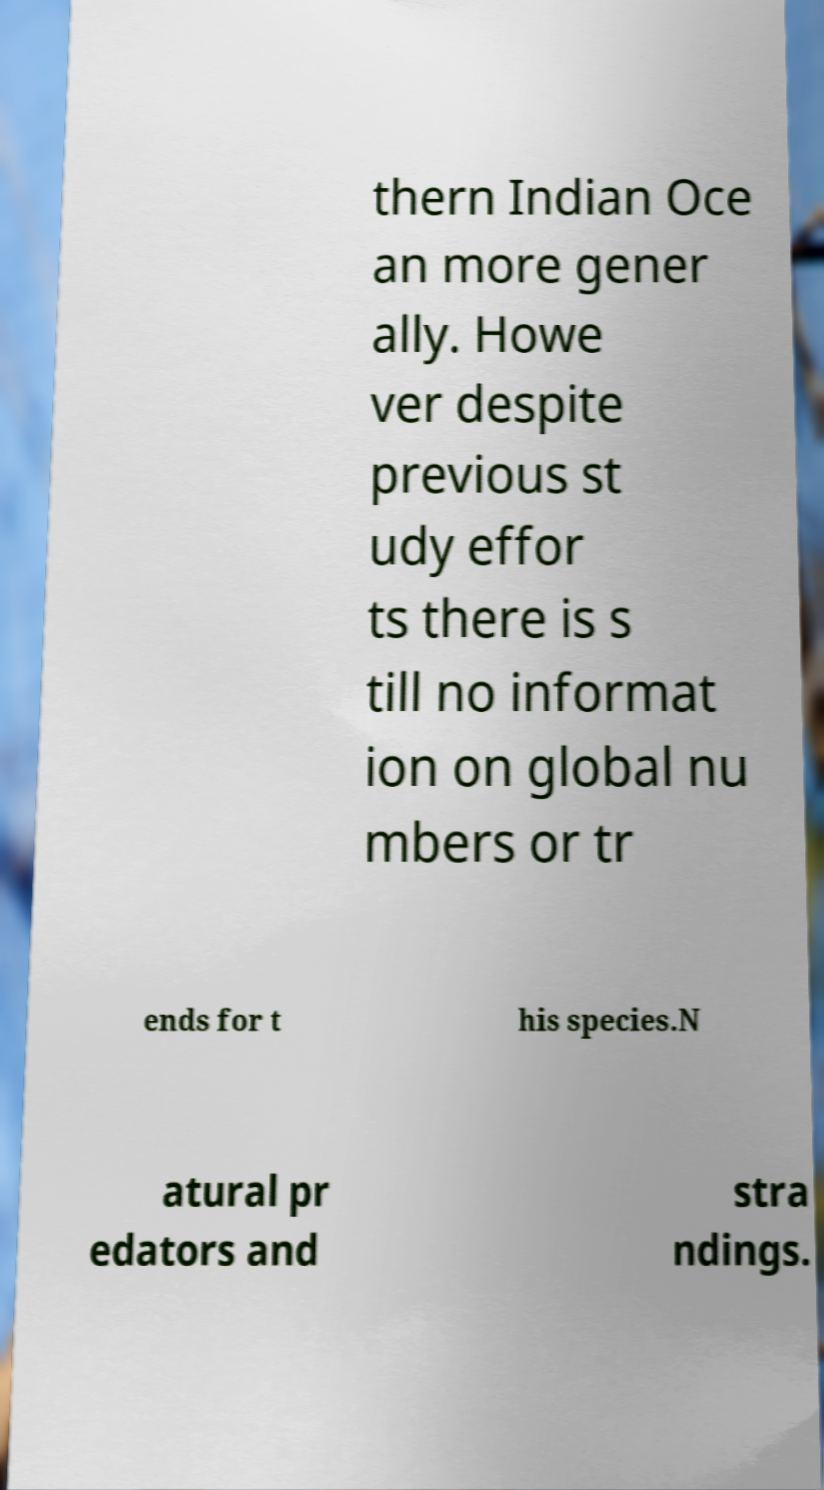What messages or text are displayed in this image? I need them in a readable, typed format. thern Indian Oce an more gener ally. Howe ver despite previous st udy effor ts there is s till no informat ion on global nu mbers or tr ends for t his species.N atural pr edators and stra ndings. 